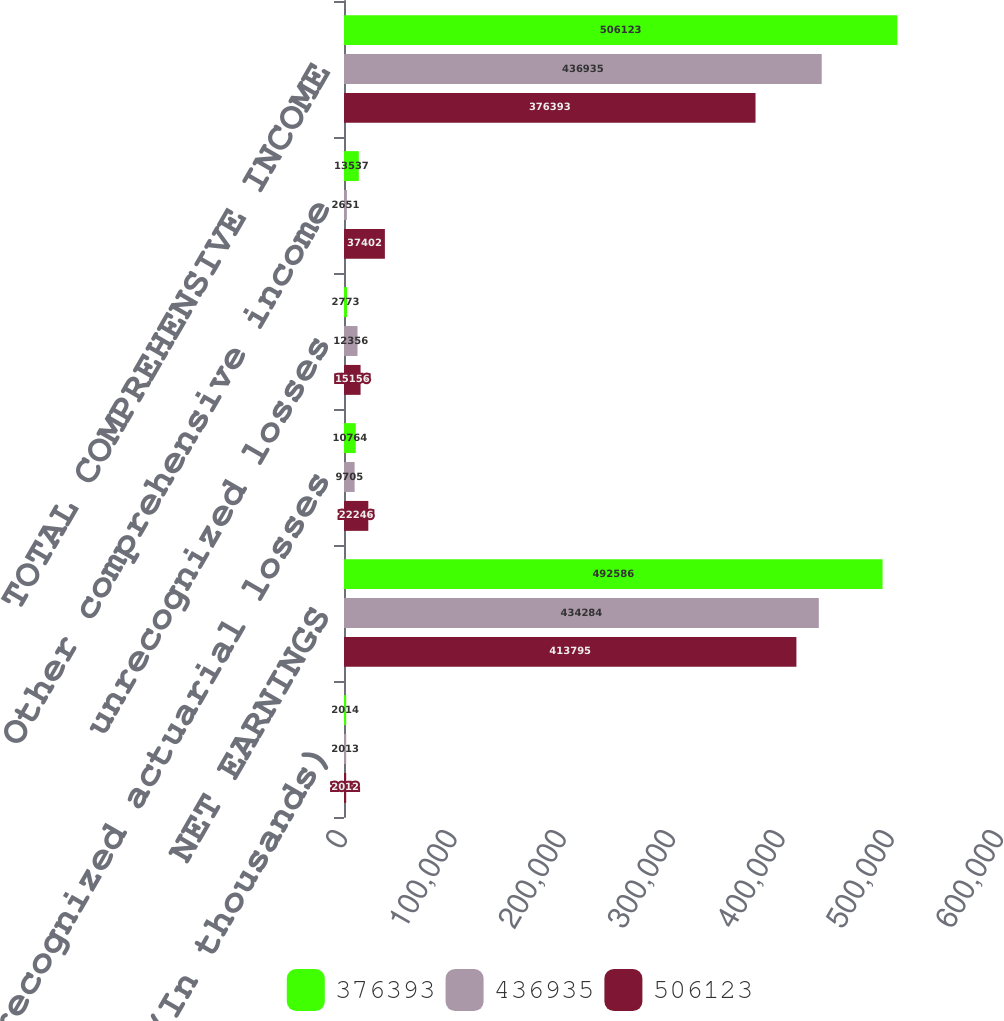<chart> <loc_0><loc_0><loc_500><loc_500><stacked_bar_chart><ecel><fcel>(In thousands)<fcel>NET EARNINGS<fcel>unrecognized actuarial losses<fcel>unrecognized losses<fcel>Other comprehensive income<fcel>TOTAL COMPREHENSIVE INCOME<nl><fcel>376393<fcel>2014<fcel>492586<fcel>10764<fcel>2773<fcel>13537<fcel>506123<nl><fcel>436935<fcel>2013<fcel>434284<fcel>9705<fcel>12356<fcel>2651<fcel>436935<nl><fcel>506123<fcel>2012<fcel>413795<fcel>22246<fcel>15156<fcel>37402<fcel>376393<nl></chart> 